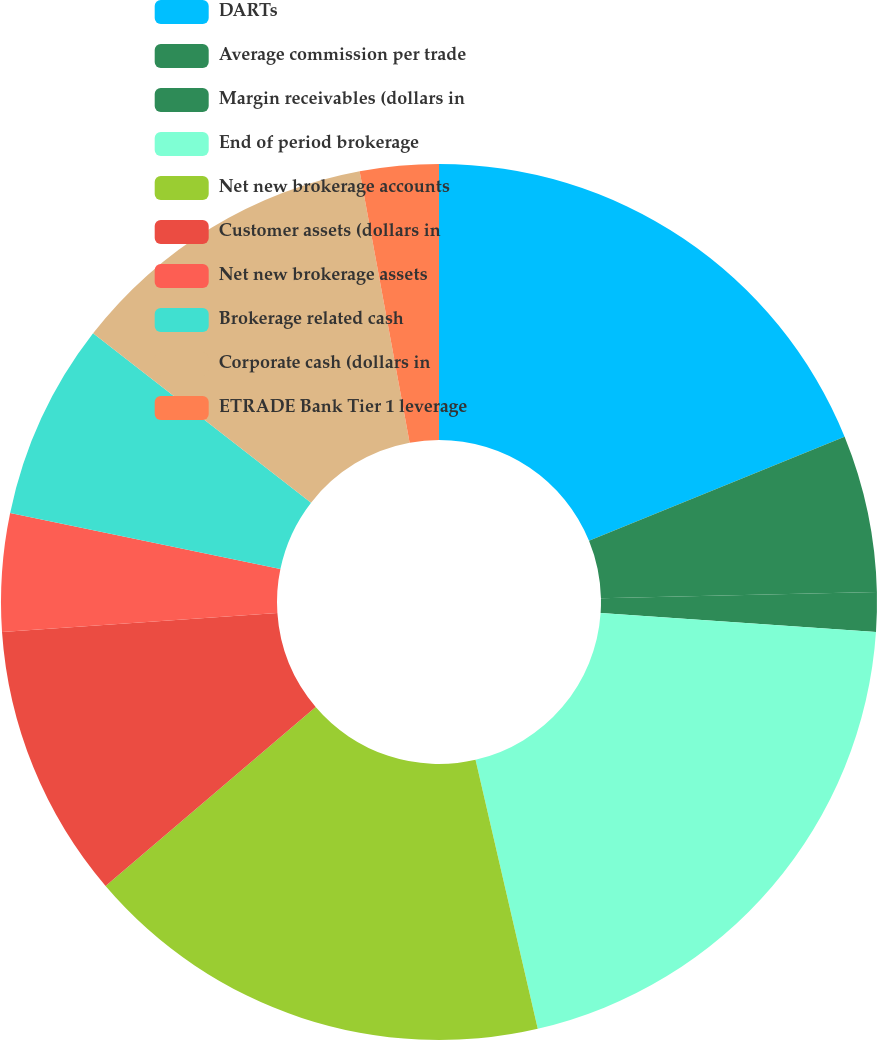Convert chart to OTSL. <chart><loc_0><loc_0><loc_500><loc_500><pie_chart><fcel>DARTs<fcel>Average commission per trade<fcel>Margin receivables (dollars in<fcel>End of period brokerage<fcel>Net new brokerage accounts<fcel>Customer assets (dollars in<fcel>Net new brokerage assets<fcel>Brokerage related cash<fcel>Corporate cash (dollars in<fcel>ETRADE Bank Tier 1 leverage<nl><fcel>18.84%<fcel>5.8%<fcel>1.45%<fcel>20.29%<fcel>17.39%<fcel>10.14%<fcel>4.35%<fcel>7.25%<fcel>11.59%<fcel>2.9%<nl></chart> 